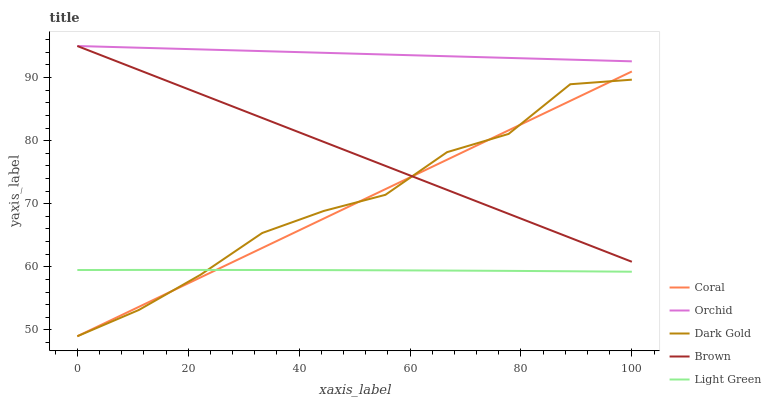Does Light Green have the minimum area under the curve?
Answer yes or no. Yes. Does Orchid have the maximum area under the curve?
Answer yes or no. Yes. Does Coral have the minimum area under the curve?
Answer yes or no. No. Does Coral have the maximum area under the curve?
Answer yes or no. No. Is Coral the smoothest?
Answer yes or no. Yes. Is Dark Gold the roughest?
Answer yes or no. Yes. Is Dark Gold the smoothest?
Answer yes or no. No. Is Coral the roughest?
Answer yes or no. No. Does Light Green have the lowest value?
Answer yes or no. No. Does Coral have the highest value?
Answer yes or no. No. Is Dark Gold less than Orchid?
Answer yes or no. Yes. Is Orchid greater than Coral?
Answer yes or no. Yes. Does Dark Gold intersect Orchid?
Answer yes or no. No. 